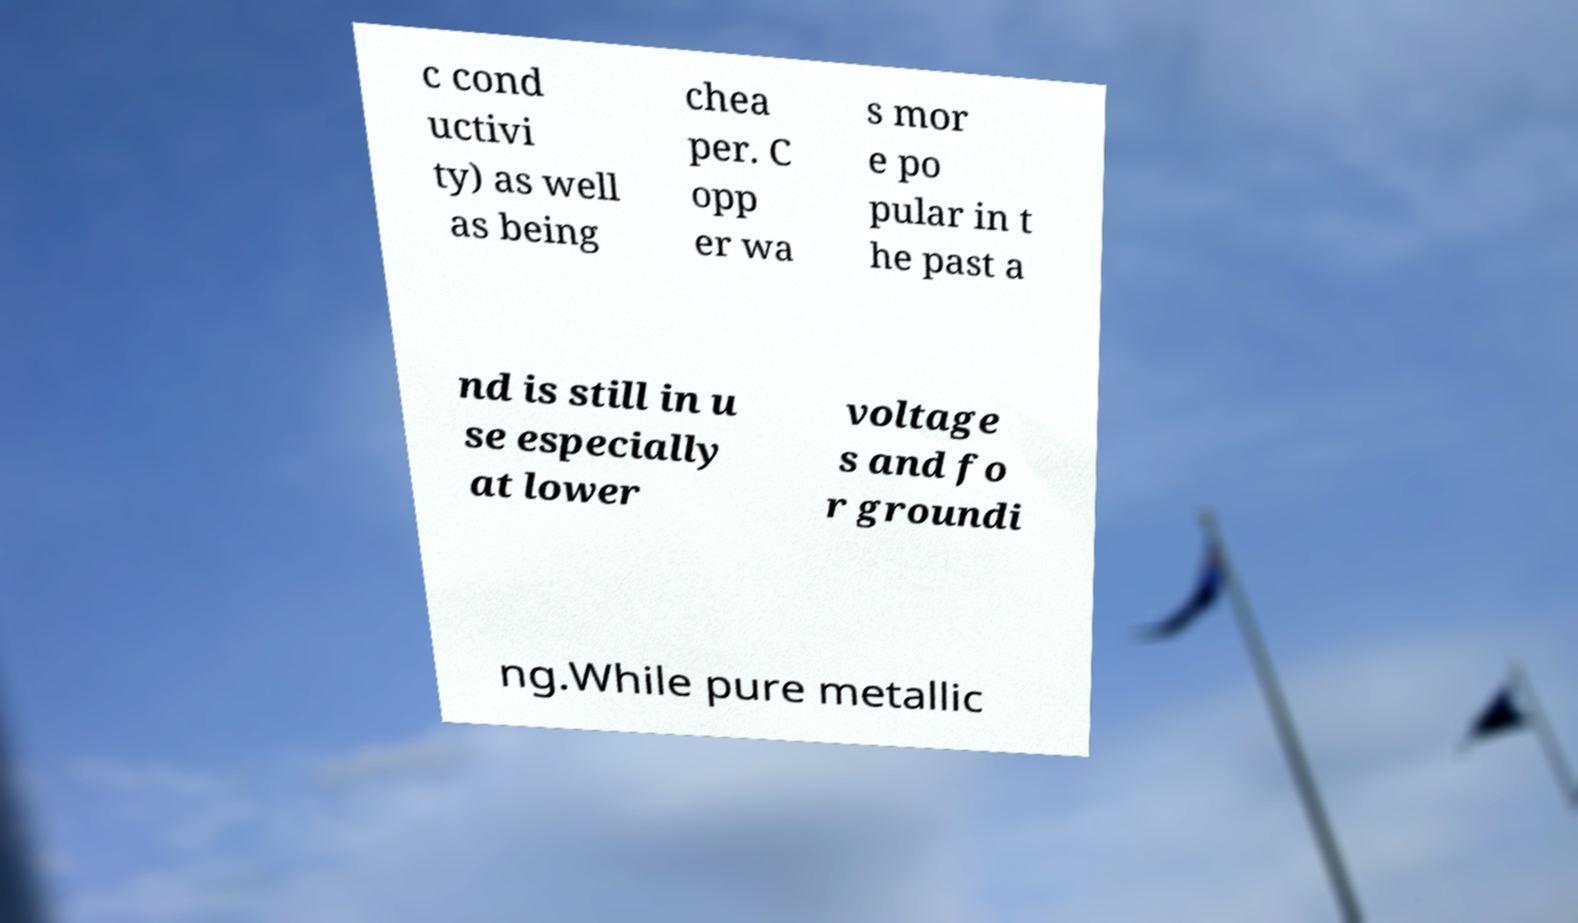There's text embedded in this image that I need extracted. Can you transcribe it verbatim? c cond uctivi ty) as well as being chea per. C opp er wa s mor e po pular in t he past a nd is still in u se especially at lower voltage s and fo r groundi ng.While pure metallic 